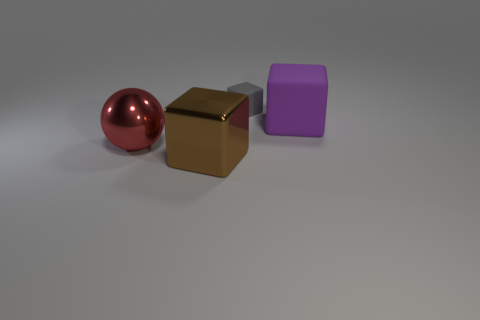Subtract all metal blocks. How many blocks are left? 2 Subtract all brown cubes. How many cubes are left? 2 Add 4 large purple blocks. How many objects exist? 8 Subtract all spheres. How many objects are left? 3 Subtract 3 blocks. How many blocks are left? 0 Subtract all brown spheres. Subtract all blue cylinders. How many spheres are left? 1 Subtract all small purple blocks. Subtract all small gray matte things. How many objects are left? 3 Add 2 large objects. How many large objects are left? 5 Add 3 large shiny cubes. How many large shiny cubes exist? 4 Subtract 0 blue cylinders. How many objects are left? 4 